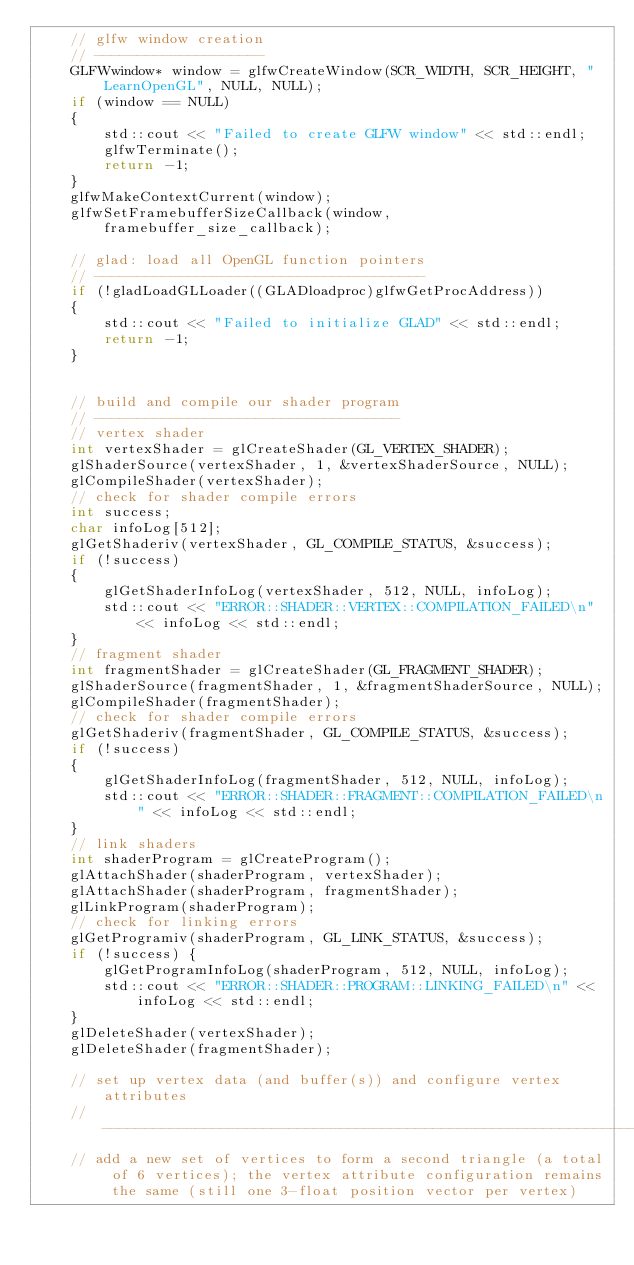<code> <loc_0><loc_0><loc_500><loc_500><_C++_>    // glfw window creation
    // --------------------
    GLFWwindow* window = glfwCreateWindow(SCR_WIDTH, SCR_HEIGHT, "LearnOpenGL", NULL, NULL);
    if (window == NULL)
    {
        std::cout << "Failed to create GLFW window" << std::endl;
        glfwTerminate();
        return -1;
    }
    glfwMakeContextCurrent(window);
    glfwSetFramebufferSizeCallback(window, framebuffer_size_callback);

    // glad: load all OpenGL function pointers
    // ---------------------------------------
    if (!gladLoadGLLoader((GLADloadproc)glfwGetProcAddress))
    {
        std::cout << "Failed to initialize GLAD" << std::endl;
        return -1;
    }


    // build and compile our shader program
    // ------------------------------------
    // vertex shader
    int vertexShader = glCreateShader(GL_VERTEX_SHADER);
    glShaderSource(vertexShader, 1, &vertexShaderSource, NULL);
    glCompileShader(vertexShader);
    // check for shader compile errors
    int success;
    char infoLog[512];
    glGetShaderiv(vertexShader, GL_COMPILE_STATUS, &success);
    if (!success)
    {
        glGetShaderInfoLog(vertexShader, 512, NULL, infoLog);
        std::cout << "ERROR::SHADER::VERTEX::COMPILATION_FAILED\n" << infoLog << std::endl;
    }
    // fragment shader
    int fragmentShader = glCreateShader(GL_FRAGMENT_SHADER);
    glShaderSource(fragmentShader, 1, &fragmentShaderSource, NULL);
    glCompileShader(fragmentShader);
    // check for shader compile errors
    glGetShaderiv(fragmentShader, GL_COMPILE_STATUS, &success);
    if (!success)
    {
        glGetShaderInfoLog(fragmentShader, 512, NULL, infoLog);
        std::cout << "ERROR::SHADER::FRAGMENT::COMPILATION_FAILED\n" << infoLog << std::endl;
    }
    // link shaders
    int shaderProgram = glCreateProgram();
    glAttachShader(shaderProgram, vertexShader);
    glAttachShader(shaderProgram, fragmentShader);
    glLinkProgram(shaderProgram);
    // check for linking errors
    glGetProgramiv(shaderProgram, GL_LINK_STATUS, &success);
    if (!success) {
        glGetProgramInfoLog(shaderProgram, 512, NULL, infoLog);
        std::cout << "ERROR::SHADER::PROGRAM::LINKING_FAILED\n" << infoLog << std::endl;
    }
    glDeleteShader(vertexShader);
    glDeleteShader(fragmentShader);

    // set up vertex data (and buffer(s)) and configure vertex attributes
    // ------------------------------------------------------------------
    // add a new set of vertices to form a second triangle (a total of 6 vertices); the vertex attribute configuration remains the same (still one 3-float position vector per vertex)</code> 